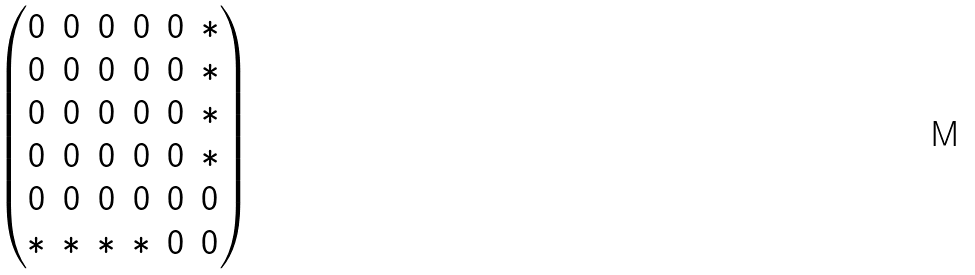<formula> <loc_0><loc_0><loc_500><loc_500>\begin{pmatrix} 0 & 0 & 0 & 0 & 0 & \ast \\ 0 & 0 & 0 & 0 & 0 & \ast \\ 0 & 0 & 0 & 0 & 0 & \ast \\ 0 & 0 & 0 & 0 & 0 & \ast \\ 0 & 0 & 0 & 0 & 0 & 0 \\ \ast & \ast & \ast & \ast & 0 & 0 \end{pmatrix}</formula> 